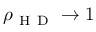Convert formula to latex. <formula><loc_0><loc_0><loc_500><loc_500>\rho _ { H D } \rightarrow 1</formula> 